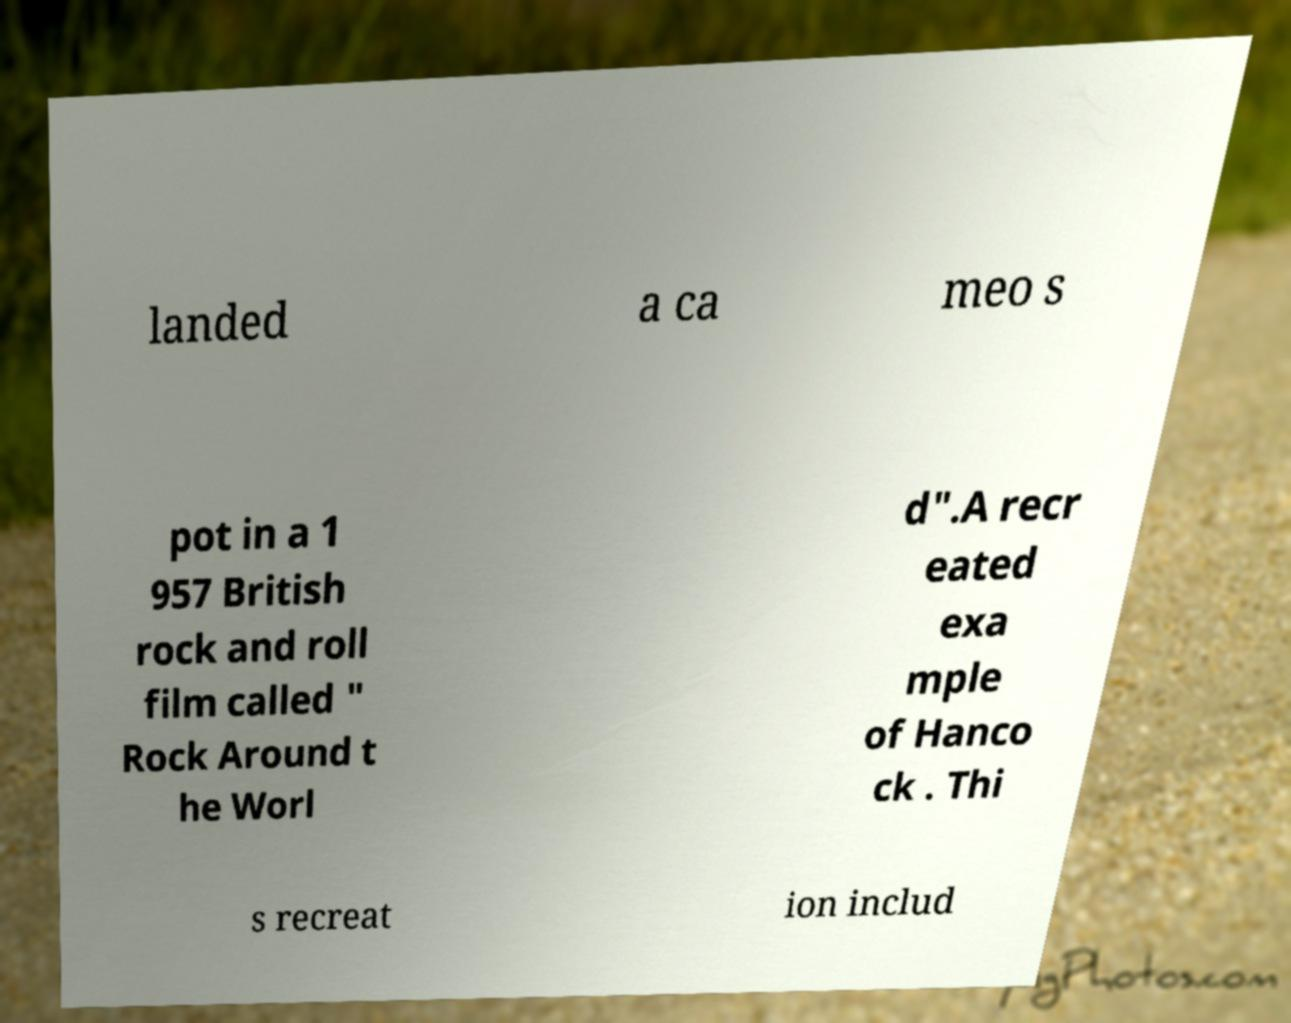Please identify and transcribe the text found in this image. landed a ca meo s pot in a 1 957 British rock and roll film called " Rock Around t he Worl d".A recr eated exa mple of Hanco ck . Thi s recreat ion includ 